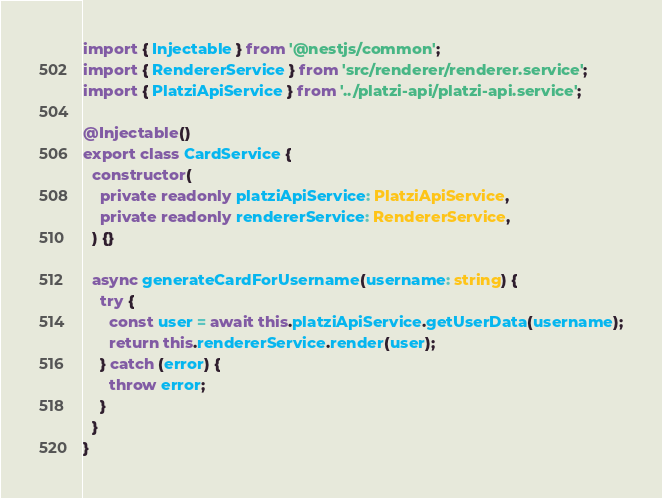Convert code to text. <code><loc_0><loc_0><loc_500><loc_500><_TypeScript_>import { Injectable } from '@nestjs/common';
import { RendererService } from 'src/renderer/renderer.service';
import { PlatziApiService } from '../platzi-api/platzi-api.service';

@Injectable()
export class CardService {
  constructor(
    private readonly platziApiService: PlatziApiService,
    private readonly rendererService: RendererService,
  ) {}

  async generateCardForUsername(username: string) {
    try {
      const user = await this.platziApiService.getUserData(username);
      return this.rendererService.render(user);
    } catch (error) {
      throw error;
    }
  }
}
</code> 